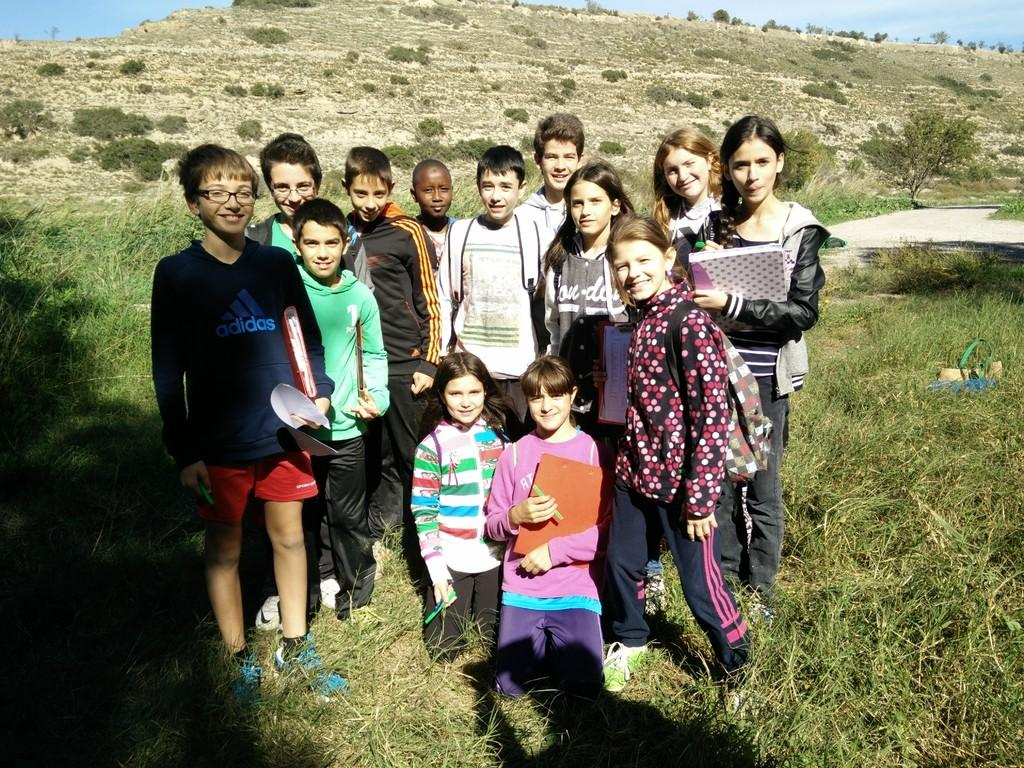What are the people in the image doing? The people in the image are standing and sitting on the grass. How do the people appear to be feeling in the image? The people have smiles on their faces, indicating they are happy or enjoying themselves. What can be seen in the background of the image? There are trees and the sky visible in the background of the image. What type of tax is being discussed by the people in the image? There is no indication in the image that the people are discussing any type of tax. How many visitors are present in the image? The image does not show any visitors; it only shows people who appear to be enjoying themselves. 